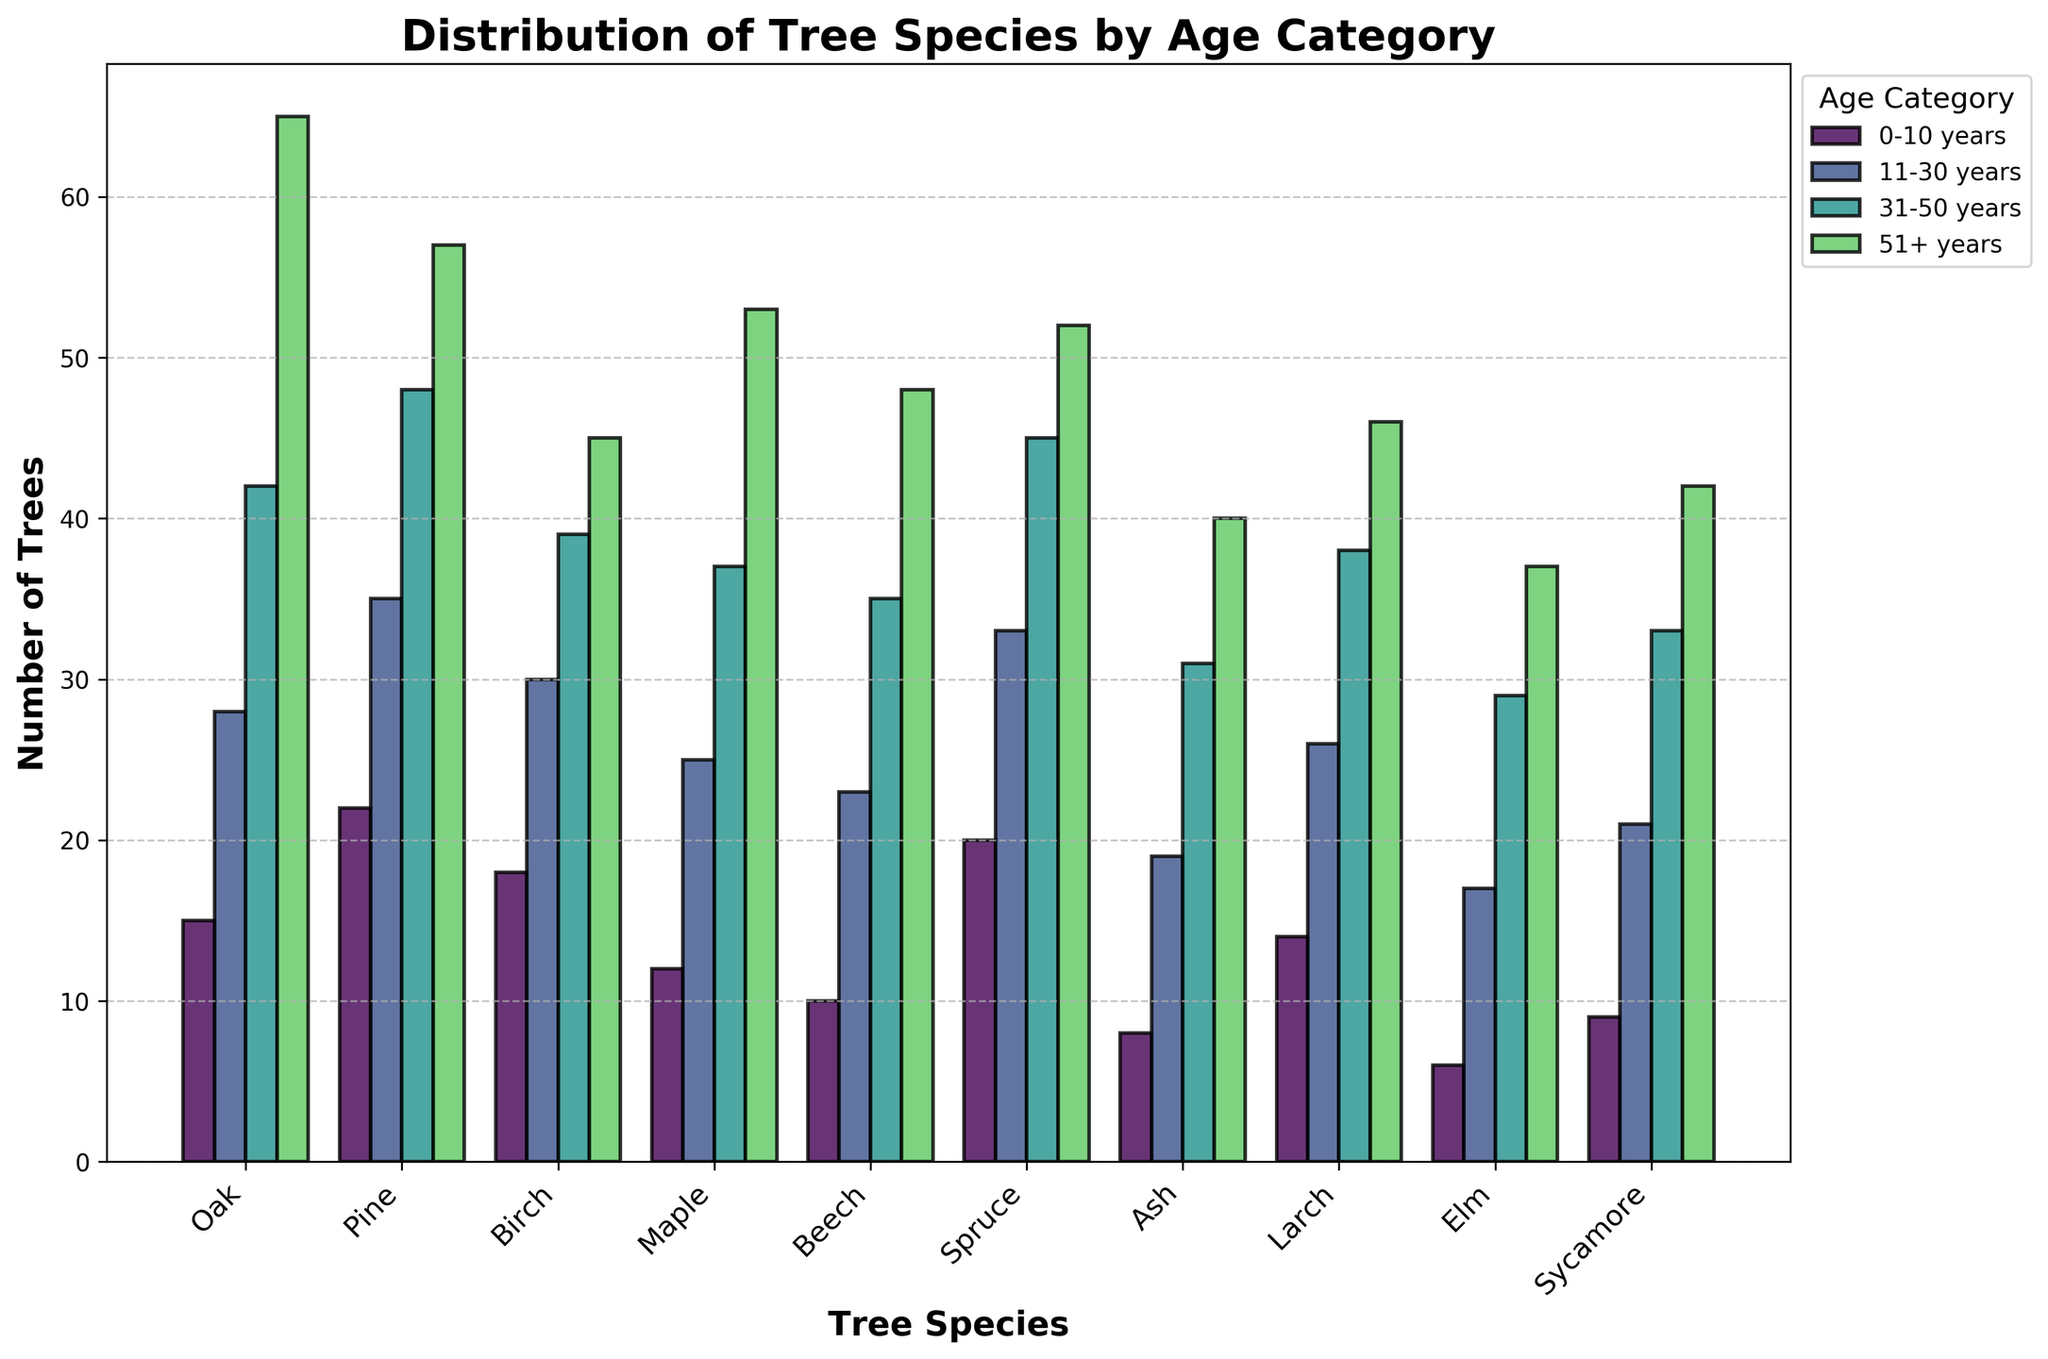Which tree species has the highest number of trees in the 0-10 years age category? By looking at the height of the bars for the 0-10 years age category, Oak has the highest number in this group, with 15 trees.
Answer: Oak Which tree species has fewer trees in the 51+ years age category, Beech or Elm? Beech has 48 trees and Elm has 37 trees in the 51+ years age category, hence Elm has fewer trees.
Answer: Elm What is the sum of the number of Pine trees in the 11-30 years and 31-50 years age categories? Pine trees are 35 in the 11-30 years category and 48 in the 31-50 years category. Summing these, we get 35 + 48 = 83.
Answer: 83 Which age category has the most number of trees for Oak species? By comparing the heights of the bars for Oak across different age categories, the 51+ years category has the highest number with 65 trees.
Answer: 51+ years How many more trees are there in the 31-50 years category for Spruce compared to Sycamore? Spruce has 45 trees in the 31-50 years category whereas Sycamore has 33 trees. The difference is 45 - 33 = 12.
Answer: 12 Which tree species has the most evenly distributed number of trees across all age categories? By comparing the heights of the bars across different age categories for each tree species, Birch shows a relatively even distribution with values 18, 30, 39, and 45.
Answer: Birch Does Birch have more trees in the 31-50 years age category than Maple in the 0-10 years age category? Birch has 39 trees in the 31-50 years age category while Maple has 12 trees in the 0-10 years age category. Thus, Birch has more trees.
Answer: Birch What's the average number of Ash trees across all age categories? The number of Ash trees across the age categories are 8, 19, 31, and 40. Summing these, we get 8 + 19 + 31 + 40 = 98. Dividing by 4, the average is 98/4 = 24.5.
Answer: 24.5 Which tree species has fewer trees in the 11-30 years age category, Elm or Sycamore? Elm has 17 trees in the 11-30 years category whereas Sycamore has 21. Hence, Elm has fewer trees.
Answer: Elm 